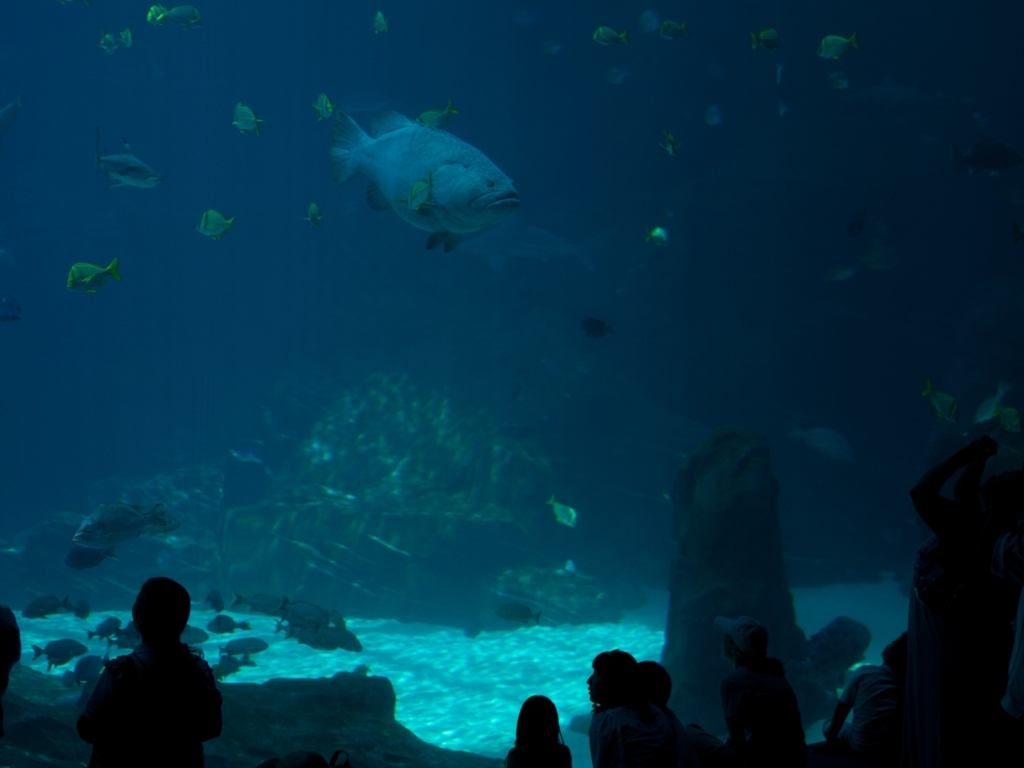Can you tell me more about the setting of this photo? Certainly! This photo depicts an underwater scene at an aquarium. The lighting is strategically dim to mimic a natural ocean habitat. Visitors are observing the marine life, which includes various fish species that are gently illuminated by an artificial light source resembling sunlight filtering through water. The arrangement suggests a serene viewing experience. What can you say about the species of fish visible in the image? The image captures a mix of species. The most prominent fish in the center appears to be a larger species, possibly a grouper, characterized by its size and shape. Surrounding it are smaller, bright yellow fish, which could be yellow tangs, known for their vivid color and disc-shaped bodies. The aquarium setting allows for a diverse cross-section of marine life to be observed. 